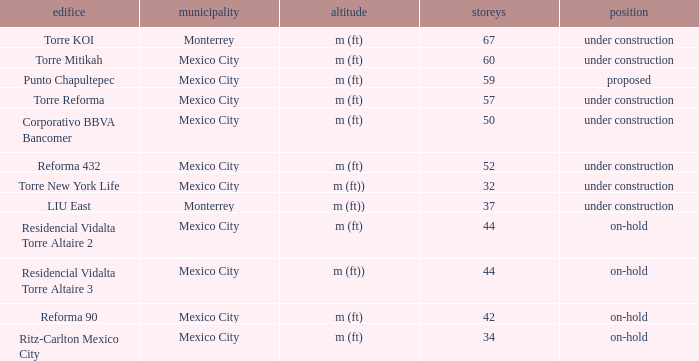What is the status of the torre reforma building that is over 44 stories in mexico city? Under construction. 